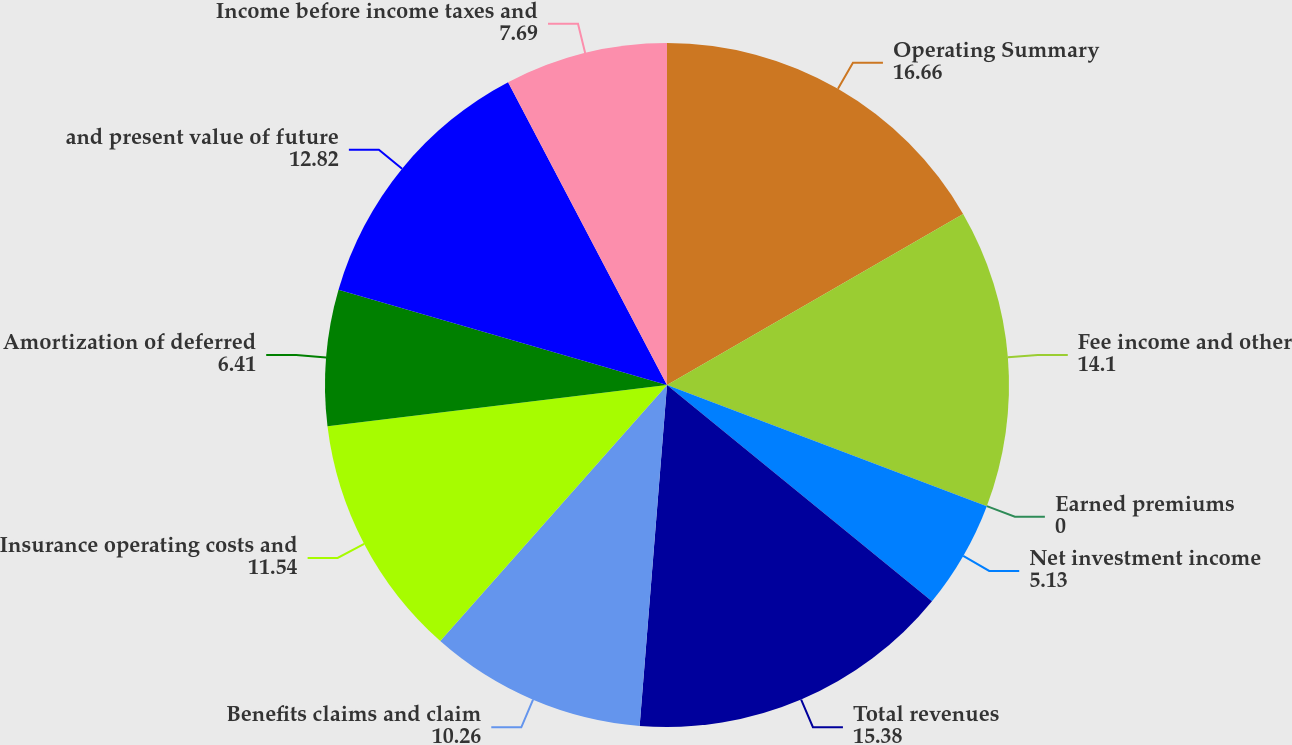Convert chart. <chart><loc_0><loc_0><loc_500><loc_500><pie_chart><fcel>Operating Summary<fcel>Fee income and other<fcel>Earned premiums<fcel>Net investment income<fcel>Total revenues<fcel>Benefits claims and claim<fcel>Insurance operating costs and<fcel>Amortization of deferred<fcel>and present value of future<fcel>Income before income taxes and<nl><fcel>16.66%<fcel>14.1%<fcel>0.0%<fcel>5.13%<fcel>15.38%<fcel>10.26%<fcel>11.54%<fcel>6.41%<fcel>12.82%<fcel>7.69%<nl></chart> 